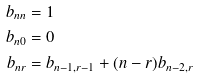Convert formula to latex. <formula><loc_0><loc_0><loc_500><loc_500>b _ { n n } & = 1 & & \\ b _ { n 0 } & = 0 & & \\ b _ { n r } & = b _ { n - 1 , r - 1 } + ( n - r ) b _ { n - 2 , r } & &</formula> 